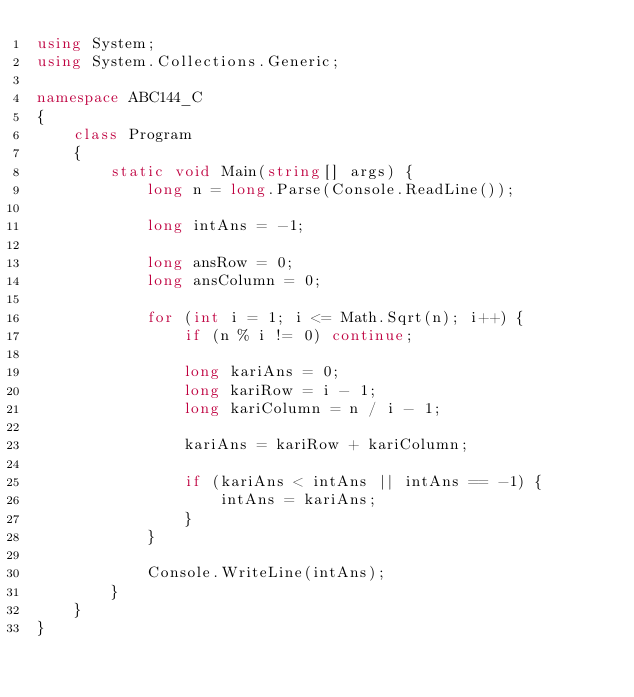<code> <loc_0><loc_0><loc_500><loc_500><_C#_>using System;
using System.Collections.Generic;

namespace ABC144_C
{
    class Program
    {
        static void Main(string[] args) {
            long n = long.Parse(Console.ReadLine());

            long intAns = -1;

            long ansRow = 0;
            long ansColumn = 0;

            for (int i = 1; i <= Math.Sqrt(n); i++) {
                if (n % i != 0) continue;

                long kariAns = 0;
                long kariRow = i - 1;
                long kariColumn = n / i - 1;

                kariAns = kariRow + kariColumn;

                if (kariAns < intAns || intAns == -1) {
                    intAns = kariAns;
                }
            }

            Console.WriteLine(intAns);
        }
    }
}</code> 